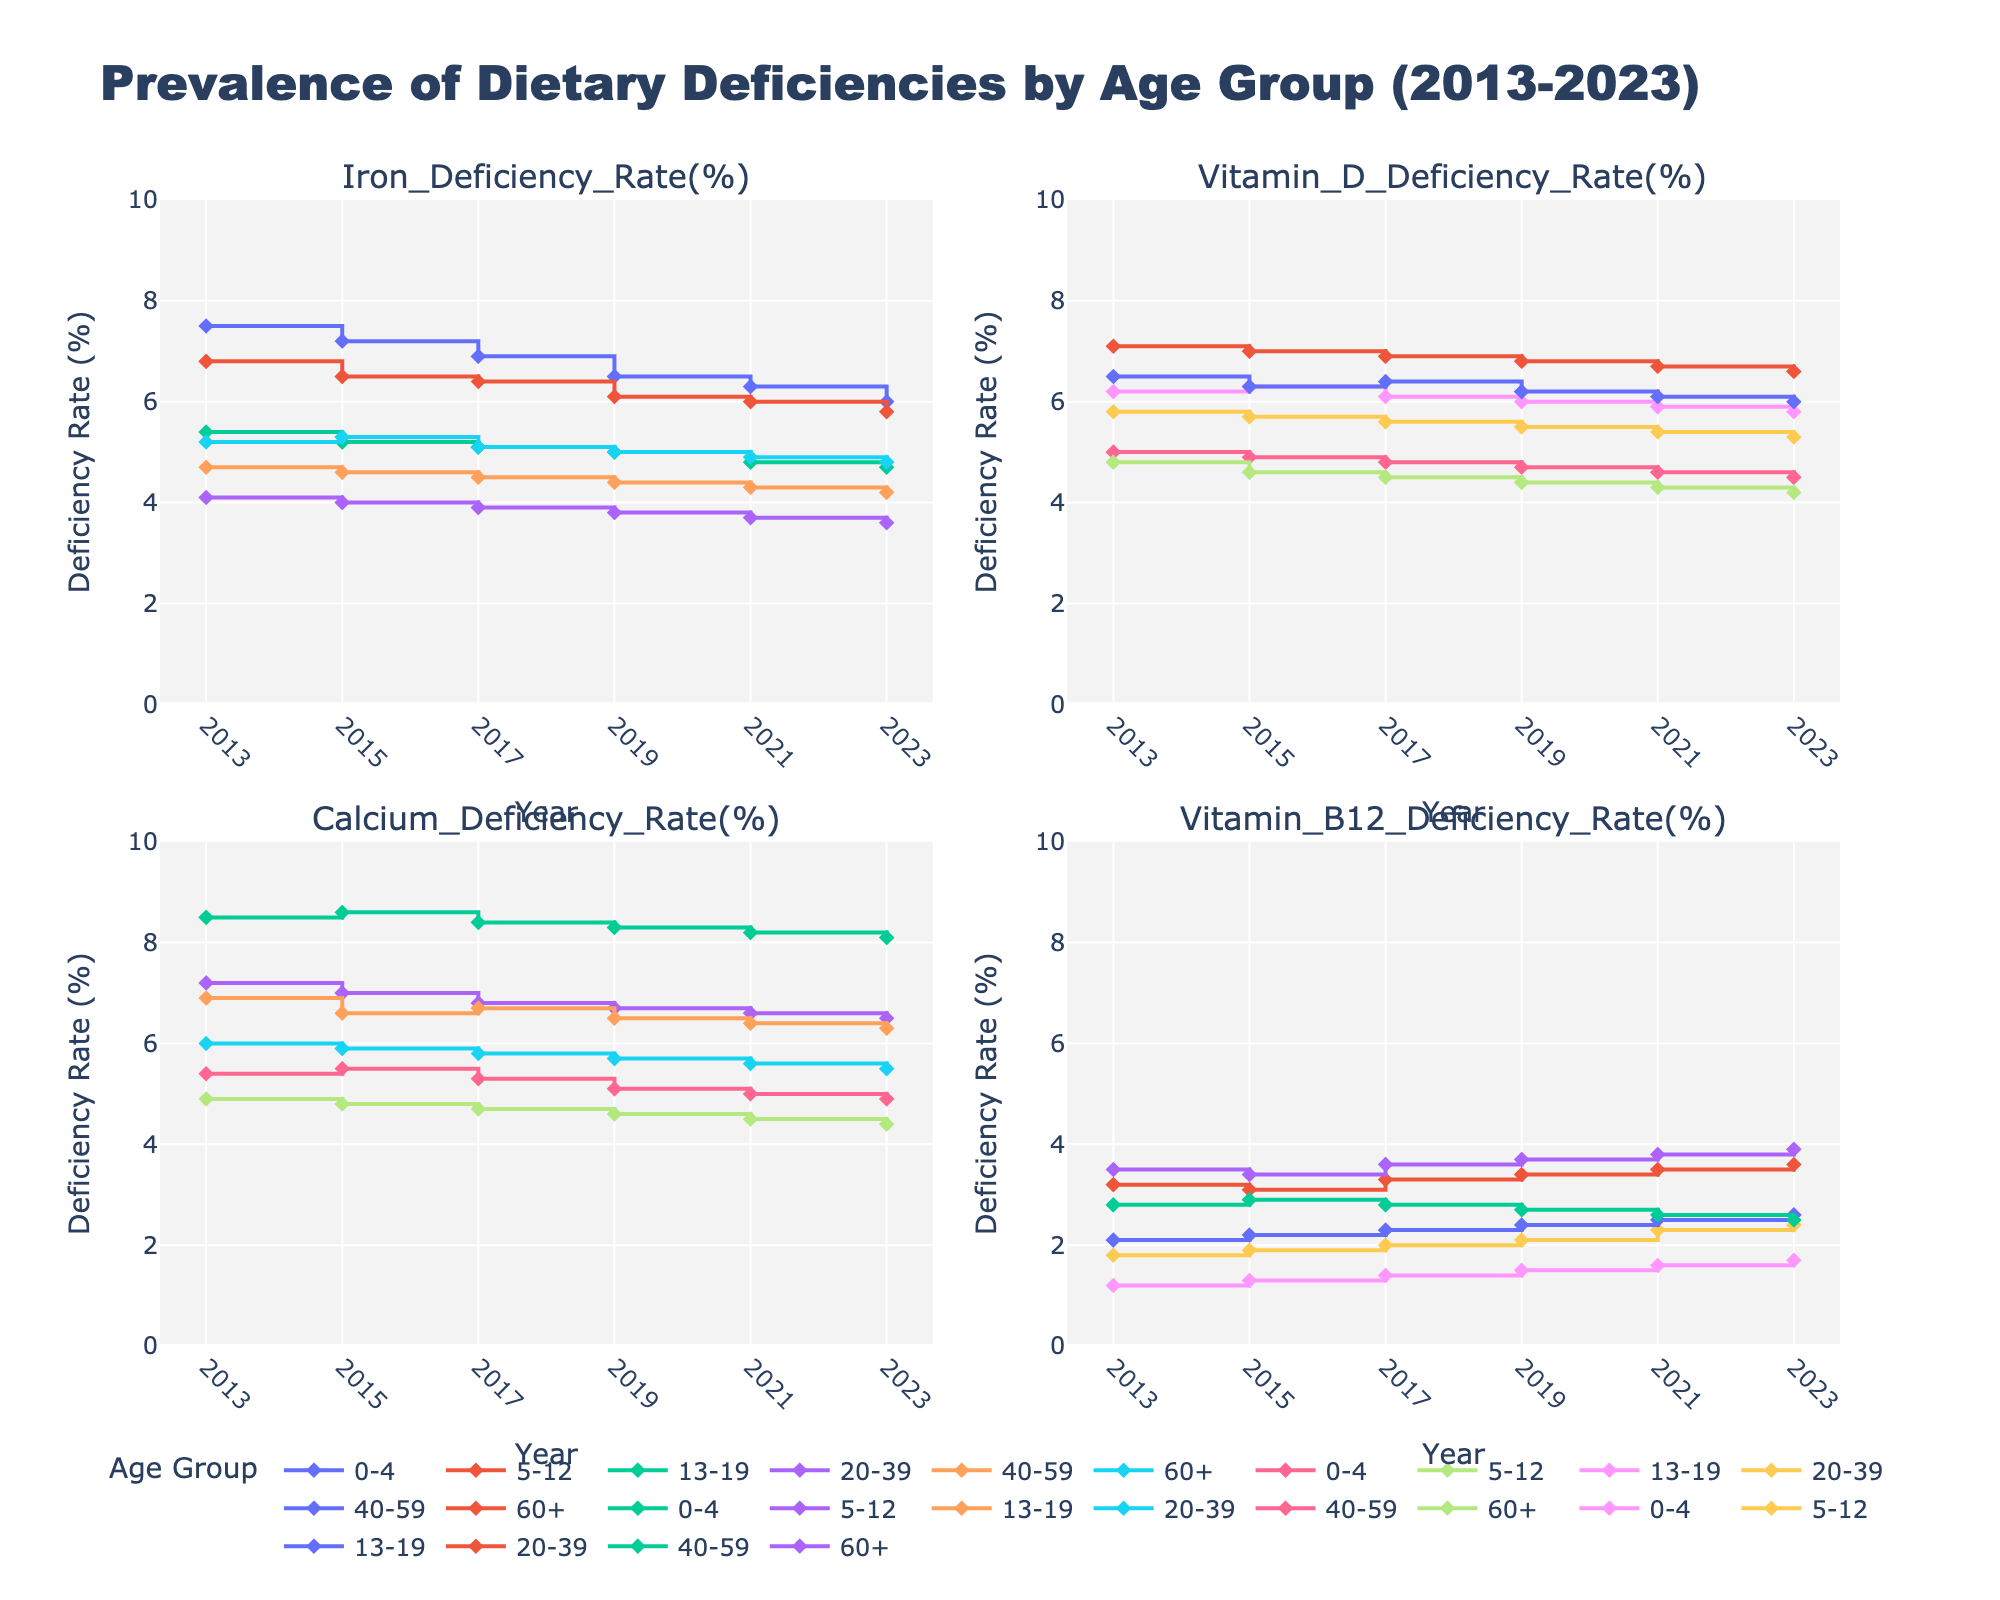What's the overall trend of Iron Deficiency in the 0-4 age group from 2013 to 2023? To determine the trend, observe the Iron Deficiency rates for the 0-4 age group across the years. Starting from 7.5% in 2013, the rate decreases steadily, reaching 6.0% by 2023.
Answer: Decreasing Which age group had the highest Vitamin D Deficiency Rate in 2021? Look at the lines corresponding to each age group in the Vitamin D Deficiency subplot and find the value at 2021. The 60+ age group shows the highest rate at 6.7%.
Answer: 60+ What is the difference in the Calcium Deficiency rate between the age groups 0-4 and 20-39 in 2023? Compare the Calcium Deficiency rates for these two age groups in 2023: 8.1% for 0-4 and 5.5% for 20-39. The difference is calculated as 8.1% - 5.5%.
Answer: 2.6% Between 2013 and 2023, which age group showed the most significant reduction in Vitamin B12 Deficiency rate? Check the Vitamin B12 Deficiency rates for all age groups in 2013 and 2023 and look for the largest drop. The 0-4 age group reduced from 1.2% to 1.7%, hence marking the most significant change.
Answer: 0-4 What common trend is observed across all age groups for Vitamin D Deficiency Rate over the years? By examining all the data points for Vitamin D Deficiency Rate, it is evident that the rates have generally decreased across all age groups from 2013 to 2023.
Answer: Decreasing In 2019, which age group had the lowest Calcium Deficiency Rate and what was the rate? Look at the Calcium Deficiency rates for all age groups in 2019. The 60+ age group had the lowest rate at 4.6%.
Answer: 60+, 4.6% How does the Iron Deficiency Rate for the 40-59 age group in 2013 compare to the same group in 2023? Compare the Iron Deficiency rates of the 40-59 age group in 2013 (4.7%) and 2023 (4.2%). 2023 shows a slightly lower rate than 2013.
Answer: 2023 lower What observations can be made about the Vitamin B12 Deficiency rate for the age group 20-39 from 2013 to 2023? The Vitamin B12 Deficiency rate for the 20-39 age group starts at 3.2% in 2013 and gradually increases to 3.6% by 2023, indicating a slight upward trend.
Answer: Increasing Did any age group consistently show the highest Iron Deficiency Rate over the years? Examine the Iron Deficiency subplot for the highest rates across all years. The 0-4 age group consistently shows the highest values, starting at 7.5% in 2013 and ending at 6.0% in 2023.
Answer: 0-4 Compare the trend of Calcium Deficiency rates for the age groups 5-12 and 60+ from 2013 to 2023. Analyze the data points for Calcium Deficiency rates of 5-12 and 60+. The 5-12 age group shows a decreasing trend from 7.2% in 2013 to 6.5% in 2023, while the 60+ age group also shows a decreasing trend from 4.9% in 2013 to 4.4% in 2023. Both groups show a decreasing trend.
Answer: Decreasing for both groups 